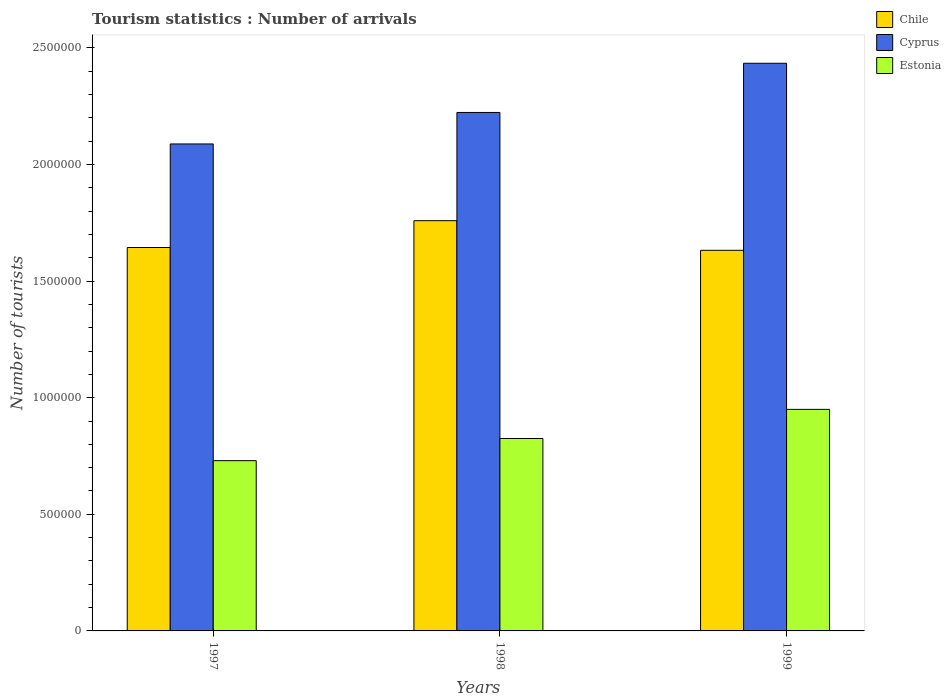How many different coloured bars are there?
Keep it short and to the point. 3. How many groups of bars are there?
Give a very brief answer. 3. Are the number of bars per tick equal to the number of legend labels?
Your response must be concise. Yes. Are the number of bars on each tick of the X-axis equal?
Ensure brevity in your answer.  Yes. In how many cases, is the number of bars for a given year not equal to the number of legend labels?
Provide a short and direct response. 0. What is the number of tourist arrivals in Estonia in 1997?
Offer a terse response. 7.30e+05. Across all years, what is the maximum number of tourist arrivals in Chile?
Provide a succinct answer. 1.76e+06. Across all years, what is the minimum number of tourist arrivals in Chile?
Provide a short and direct response. 1.63e+06. In which year was the number of tourist arrivals in Cyprus maximum?
Ensure brevity in your answer.  1999. In which year was the number of tourist arrivals in Chile minimum?
Offer a very short reply. 1999. What is the total number of tourist arrivals in Estonia in the graph?
Offer a terse response. 2.50e+06. What is the difference between the number of tourist arrivals in Chile in 1998 and that in 1999?
Your response must be concise. 1.27e+05. What is the difference between the number of tourist arrivals in Chile in 1998 and the number of tourist arrivals in Cyprus in 1999?
Your answer should be very brief. -6.75e+05. What is the average number of tourist arrivals in Cyprus per year?
Provide a short and direct response. 2.25e+06. In the year 1999, what is the difference between the number of tourist arrivals in Estonia and number of tourist arrivals in Cyprus?
Provide a short and direct response. -1.48e+06. What is the ratio of the number of tourist arrivals in Cyprus in 1997 to that in 1999?
Provide a succinct answer. 0.86. Is the difference between the number of tourist arrivals in Estonia in 1997 and 1999 greater than the difference between the number of tourist arrivals in Cyprus in 1997 and 1999?
Your answer should be compact. Yes. What is the difference between the highest and the second highest number of tourist arrivals in Chile?
Your answer should be very brief. 1.15e+05. What is the difference between the highest and the lowest number of tourist arrivals in Estonia?
Keep it short and to the point. 2.20e+05. What does the 3rd bar from the left in 1998 represents?
Make the answer very short. Estonia. What does the 2nd bar from the right in 1999 represents?
Make the answer very short. Cyprus. Is it the case that in every year, the sum of the number of tourist arrivals in Chile and number of tourist arrivals in Estonia is greater than the number of tourist arrivals in Cyprus?
Provide a short and direct response. Yes. How many years are there in the graph?
Give a very brief answer. 3. Does the graph contain grids?
Make the answer very short. No. How many legend labels are there?
Your answer should be compact. 3. What is the title of the graph?
Offer a very short reply. Tourism statistics : Number of arrivals. What is the label or title of the X-axis?
Keep it short and to the point. Years. What is the label or title of the Y-axis?
Give a very brief answer. Number of tourists. What is the Number of tourists in Chile in 1997?
Give a very brief answer. 1.64e+06. What is the Number of tourists in Cyprus in 1997?
Your answer should be compact. 2.09e+06. What is the Number of tourists in Estonia in 1997?
Your answer should be compact. 7.30e+05. What is the Number of tourists of Chile in 1998?
Give a very brief answer. 1.76e+06. What is the Number of tourists in Cyprus in 1998?
Give a very brief answer. 2.22e+06. What is the Number of tourists of Estonia in 1998?
Offer a terse response. 8.25e+05. What is the Number of tourists of Chile in 1999?
Provide a short and direct response. 1.63e+06. What is the Number of tourists in Cyprus in 1999?
Provide a short and direct response. 2.43e+06. What is the Number of tourists of Estonia in 1999?
Ensure brevity in your answer.  9.50e+05. Across all years, what is the maximum Number of tourists in Chile?
Give a very brief answer. 1.76e+06. Across all years, what is the maximum Number of tourists of Cyprus?
Offer a terse response. 2.43e+06. Across all years, what is the maximum Number of tourists of Estonia?
Ensure brevity in your answer.  9.50e+05. Across all years, what is the minimum Number of tourists in Chile?
Make the answer very short. 1.63e+06. Across all years, what is the minimum Number of tourists in Cyprus?
Provide a short and direct response. 2.09e+06. Across all years, what is the minimum Number of tourists of Estonia?
Offer a terse response. 7.30e+05. What is the total Number of tourists of Chile in the graph?
Make the answer very short. 5.04e+06. What is the total Number of tourists of Cyprus in the graph?
Ensure brevity in your answer.  6.74e+06. What is the total Number of tourists in Estonia in the graph?
Your response must be concise. 2.50e+06. What is the difference between the Number of tourists in Chile in 1997 and that in 1998?
Offer a very short reply. -1.15e+05. What is the difference between the Number of tourists in Cyprus in 1997 and that in 1998?
Your answer should be very brief. -1.35e+05. What is the difference between the Number of tourists of Estonia in 1997 and that in 1998?
Keep it short and to the point. -9.50e+04. What is the difference between the Number of tourists in Chile in 1997 and that in 1999?
Your answer should be very brief. 1.20e+04. What is the difference between the Number of tourists in Cyprus in 1997 and that in 1999?
Make the answer very short. -3.46e+05. What is the difference between the Number of tourists of Chile in 1998 and that in 1999?
Your answer should be very brief. 1.27e+05. What is the difference between the Number of tourists in Cyprus in 1998 and that in 1999?
Provide a succinct answer. -2.11e+05. What is the difference between the Number of tourists in Estonia in 1998 and that in 1999?
Give a very brief answer. -1.25e+05. What is the difference between the Number of tourists of Chile in 1997 and the Number of tourists of Cyprus in 1998?
Make the answer very short. -5.79e+05. What is the difference between the Number of tourists in Chile in 1997 and the Number of tourists in Estonia in 1998?
Your response must be concise. 8.19e+05. What is the difference between the Number of tourists of Cyprus in 1997 and the Number of tourists of Estonia in 1998?
Offer a very short reply. 1.26e+06. What is the difference between the Number of tourists of Chile in 1997 and the Number of tourists of Cyprus in 1999?
Your answer should be very brief. -7.90e+05. What is the difference between the Number of tourists in Chile in 1997 and the Number of tourists in Estonia in 1999?
Offer a terse response. 6.94e+05. What is the difference between the Number of tourists of Cyprus in 1997 and the Number of tourists of Estonia in 1999?
Your answer should be very brief. 1.14e+06. What is the difference between the Number of tourists in Chile in 1998 and the Number of tourists in Cyprus in 1999?
Offer a terse response. -6.75e+05. What is the difference between the Number of tourists of Chile in 1998 and the Number of tourists of Estonia in 1999?
Your answer should be compact. 8.09e+05. What is the difference between the Number of tourists in Cyprus in 1998 and the Number of tourists in Estonia in 1999?
Your answer should be very brief. 1.27e+06. What is the average Number of tourists in Chile per year?
Give a very brief answer. 1.68e+06. What is the average Number of tourists of Cyprus per year?
Ensure brevity in your answer.  2.25e+06. What is the average Number of tourists in Estonia per year?
Provide a short and direct response. 8.35e+05. In the year 1997, what is the difference between the Number of tourists in Chile and Number of tourists in Cyprus?
Your response must be concise. -4.44e+05. In the year 1997, what is the difference between the Number of tourists in Chile and Number of tourists in Estonia?
Make the answer very short. 9.14e+05. In the year 1997, what is the difference between the Number of tourists of Cyprus and Number of tourists of Estonia?
Offer a terse response. 1.36e+06. In the year 1998, what is the difference between the Number of tourists in Chile and Number of tourists in Cyprus?
Your response must be concise. -4.64e+05. In the year 1998, what is the difference between the Number of tourists of Chile and Number of tourists of Estonia?
Provide a short and direct response. 9.34e+05. In the year 1998, what is the difference between the Number of tourists in Cyprus and Number of tourists in Estonia?
Your answer should be very brief. 1.40e+06. In the year 1999, what is the difference between the Number of tourists in Chile and Number of tourists in Cyprus?
Provide a short and direct response. -8.02e+05. In the year 1999, what is the difference between the Number of tourists of Chile and Number of tourists of Estonia?
Keep it short and to the point. 6.82e+05. In the year 1999, what is the difference between the Number of tourists in Cyprus and Number of tourists in Estonia?
Your answer should be compact. 1.48e+06. What is the ratio of the Number of tourists of Chile in 1997 to that in 1998?
Ensure brevity in your answer.  0.93. What is the ratio of the Number of tourists in Cyprus in 1997 to that in 1998?
Your response must be concise. 0.94. What is the ratio of the Number of tourists in Estonia in 1997 to that in 1998?
Your answer should be very brief. 0.88. What is the ratio of the Number of tourists of Chile in 1997 to that in 1999?
Provide a short and direct response. 1.01. What is the ratio of the Number of tourists in Cyprus in 1997 to that in 1999?
Your answer should be compact. 0.86. What is the ratio of the Number of tourists in Estonia in 1997 to that in 1999?
Provide a short and direct response. 0.77. What is the ratio of the Number of tourists of Chile in 1998 to that in 1999?
Your answer should be compact. 1.08. What is the ratio of the Number of tourists in Cyprus in 1998 to that in 1999?
Your response must be concise. 0.91. What is the ratio of the Number of tourists in Estonia in 1998 to that in 1999?
Provide a short and direct response. 0.87. What is the difference between the highest and the second highest Number of tourists of Chile?
Ensure brevity in your answer.  1.15e+05. What is the difference between the highest and the second highest Number of tourists of Cyprus?
Ensure brevity in your answer.  2.11e+05. What is the difference between the highest and the second highest Number of tourists in Estonia?
Offer a very short reply. 1.25e+05. What is the difference between the highest and the lowest Number of tourists of Chile?
Make the answer very short. 1.27e+05. What is the difference between the highest and the lowest Number of tourists in Cyprus?
Your response must be concise. 3.46e+05. What is the difference between the highest and the lowest Number of tourists of Estonia?
Keep it short and to the point. 2.20e+05. 